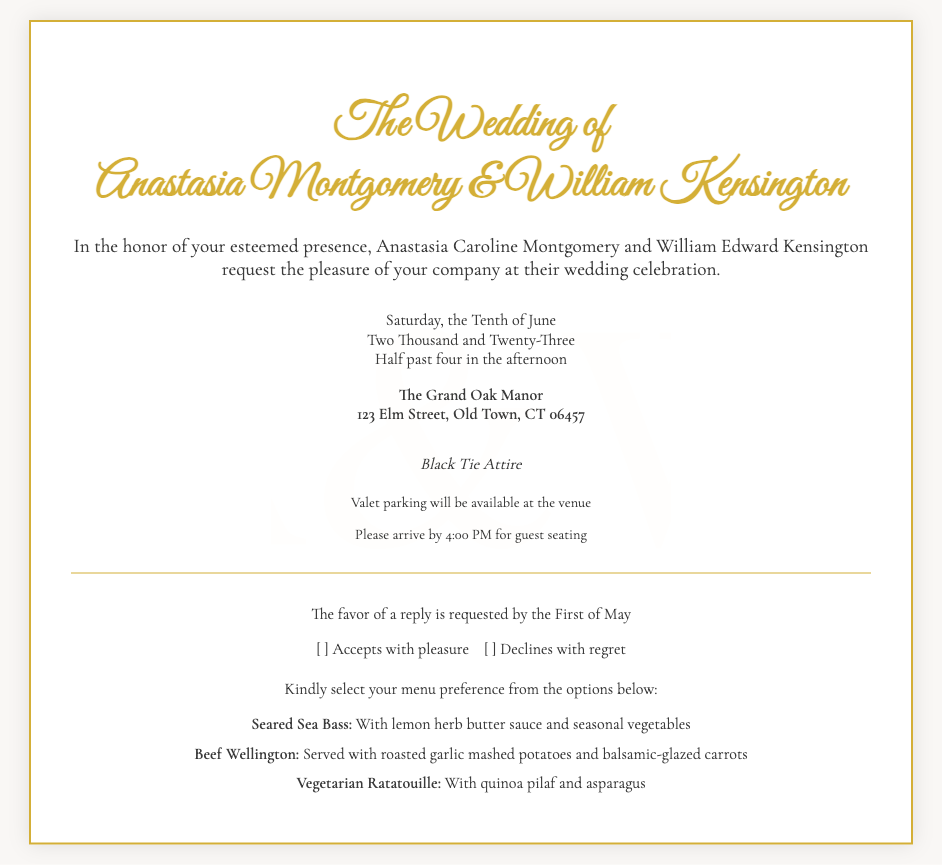What is the date of the wedding? The date is explicitly mentioned in the details section of the document.
Answer: Saturday, the Tenth of June What time does the wedding ceremony start? The starting time is provided in the details section.
Answer: Half past four in the afternoon Who are the couple getting married? The names of the couple are listed prominently in the title of the invitation.
Answer: Anastasia Montgomery & William Kensington What is the dress code for the wedding? The dress code is specified in a dedicated section on the invitation.
Answer: Black Tie Attire Where is the wedding venue located? The venue is mentioned along with its address in the details section.
Answer: The Grand Oak Manor, 123 Elm Street, Old Town, CT 06457 What is requested by the First of May? The RSVP request is explicitly mentioned in a dedicated section.
Answer: The favor of a reply How many menu options are provided for the guests? The document enumerates the menu options available for selection.
Answer: Three What type of parking is available at the venue? The availability of parking is specified in the additional information section.
Answer: Valet parking What is one of the menu options listed? The menu options are detailed, and any specific item can be mentioned.
Answer: Seared Sea Bass 